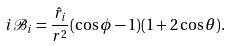<formula> <loc_0><loc_0><loc_500><loc_500>i { \mathcal { B } } _ { i } = \frac { \hat { r } _ { i } } { r ^ { 2 } } ( \cos \phi - 1 ) ( 1 + 2 \cos \theta ) .</formula> 